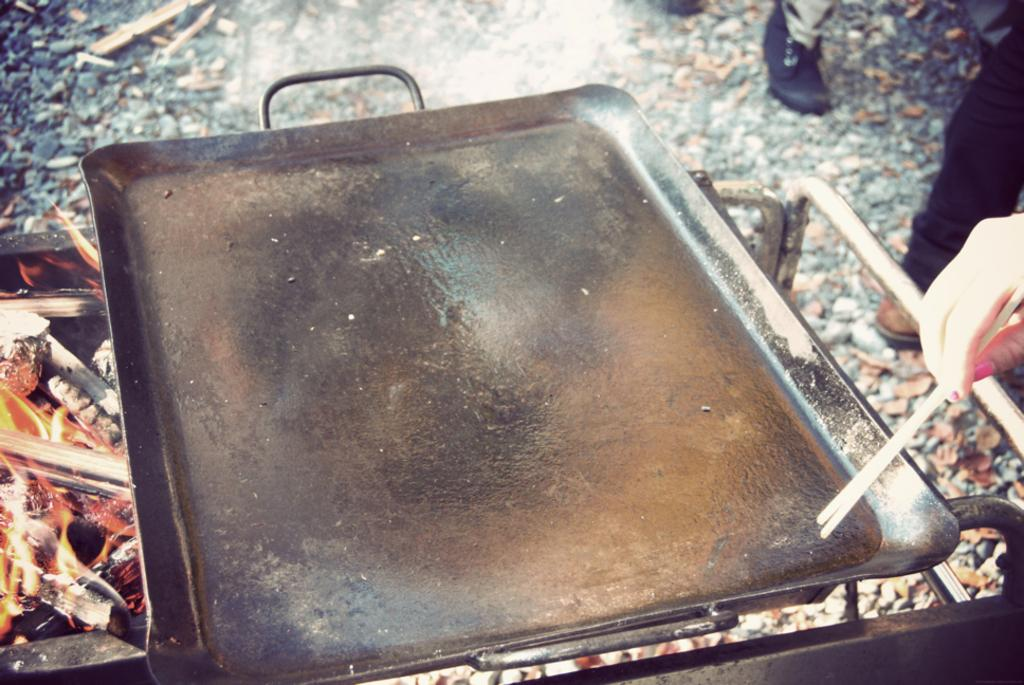What is located in the middle of the image? There is a pan in the middle of the image. What can be seen on the left side of the image? There is fire on the left side of the image. What is the human hand doing in the image? The hand is holding chopsticks on the right side of the image. What type of mint is being used to measure the ice in the image? There is no mint or ice present in the image; it features a pan, fire, and a hand holding chopsticks. 